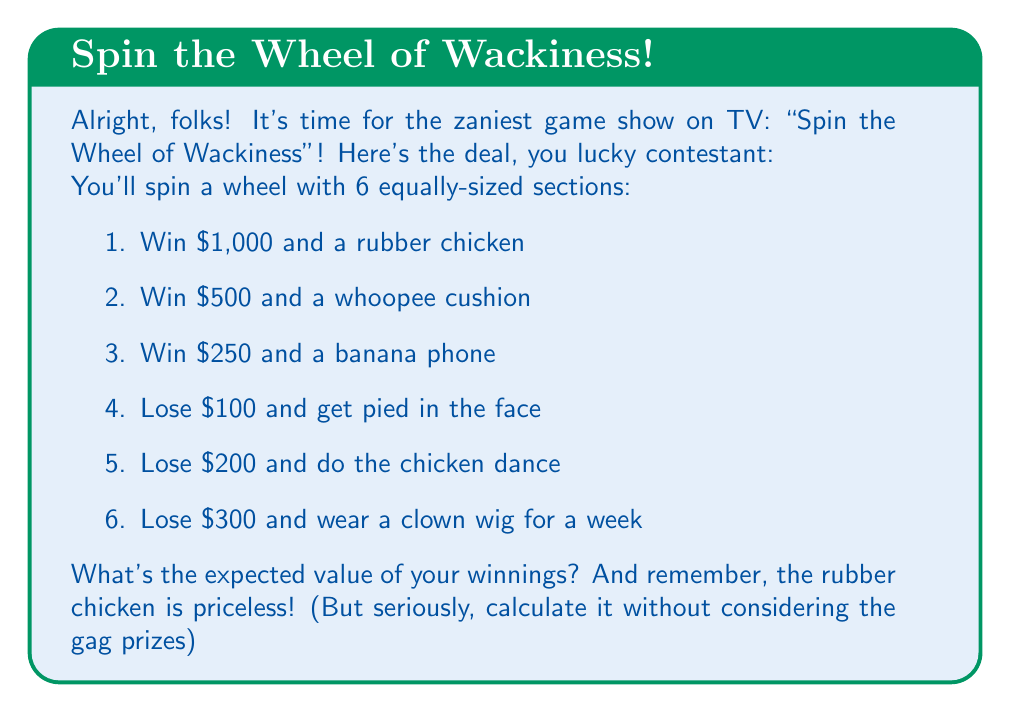Show me your answer to this math problem. Let's break this down step-by-step:

1) First, we need to identify the probability of each outcome. Since there are 6 equally-sized sections, the probability of landing on any section is $\frac{1}{6}$.

2) Now, let's list out the monetary values for each outcome:
   - $1000
   - $500
   - $250
   - $-100
   - $-200
   - $-300

3) The expected value is calculated by multiplying each possible outcome by its probability and then summing these products. In mathematical notation:

   $$ E(X) = \sum_{i=1}^{n} x_i \cdot p(x_i) $$

   Where $x_i$ is each possible outcome and $p(x_i)$ is its probability.

4) Let's calculate:

   $$ E(X) = 1000 \cdot \frac{1}{6} + 500 \cdot \frac{1}{6} + 250 \cdot \frac{1}{6} + (-100) \cdot \frac{1}{6} + (-200) \cdot \frac{1}{6} + (-300) \cdot \frac{1}{6} $$

5) Simplifying:

   $$ E(X) = \frac{1000 + 500 + 250 - 100 - 200 - 300}{6} = \frac{1150}{6} $$

6) Calculating the final result:

   $$ E(X) = 191.67 $$

Therefore, the expected value of playing this wacky game is $191.67.
Answer: $191.67 